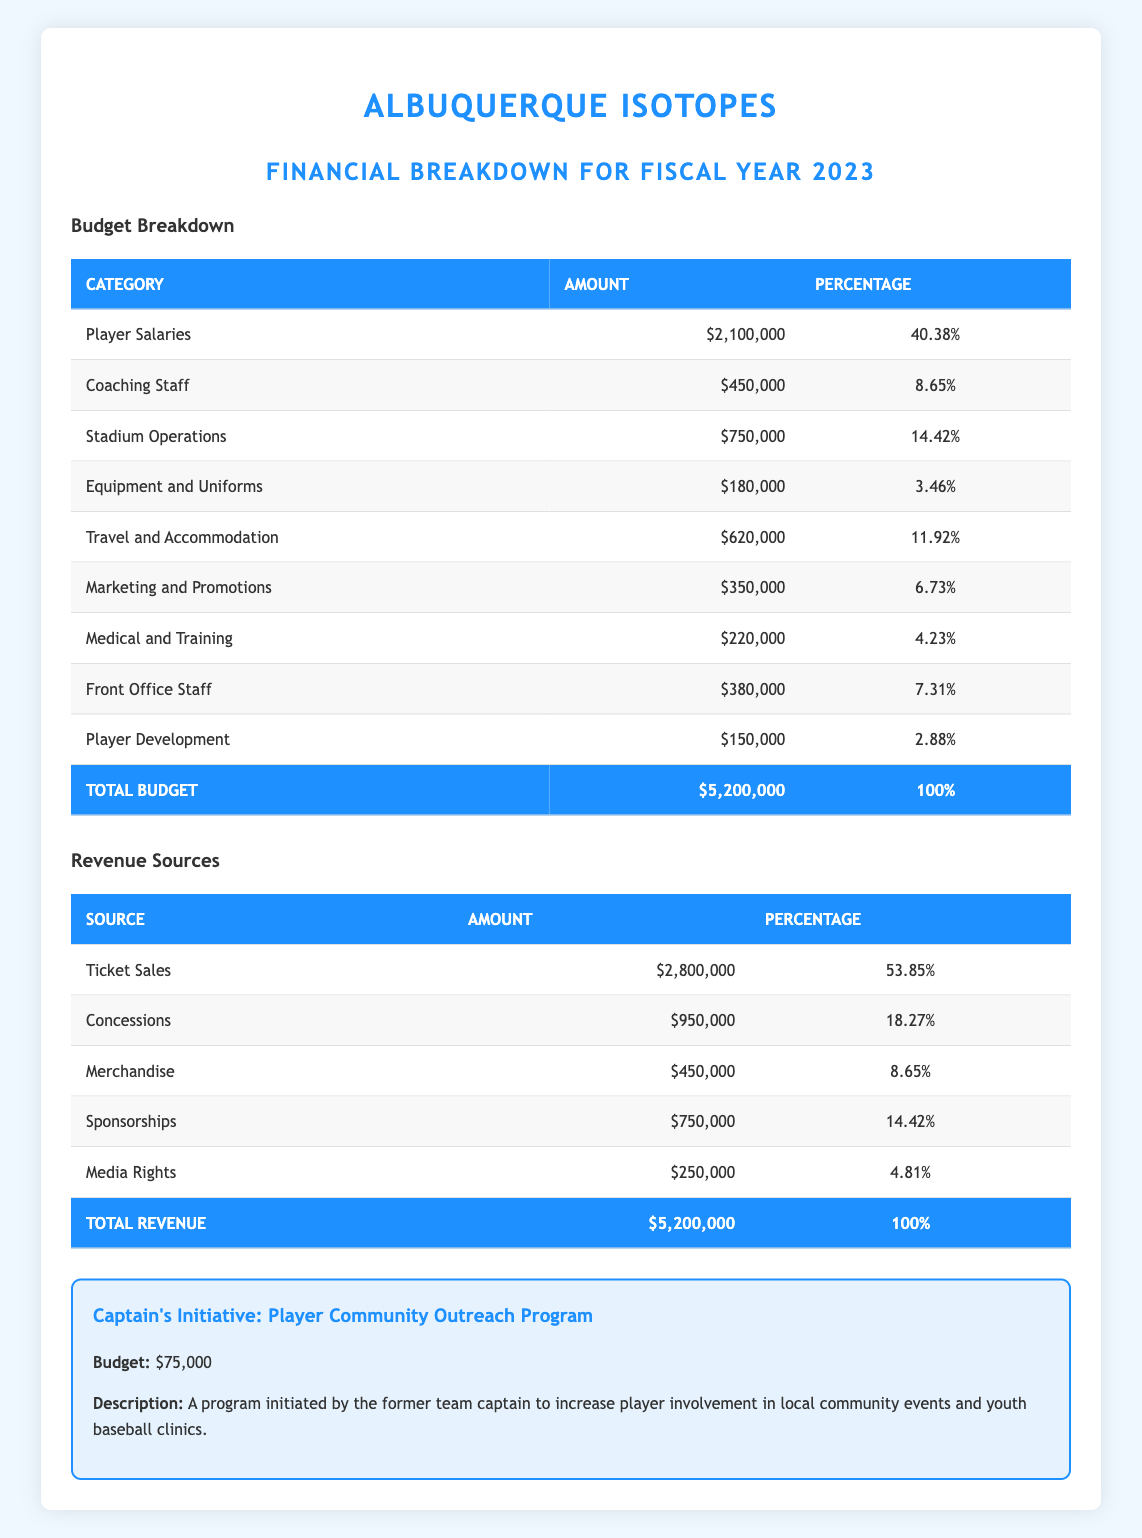What is the total budget for the Albuquerque Isotopes in 2023? The total budget listed in the table shows $5,200,000 for the fiscal year 2023.
Answer: 5,200,000 What percentage of the total budget is allocated to player salaries? The budget breakdown indicates that player salaries are allocated 40.38% of the total budget, which is $2,100,000.
Answer: 40.38% What is the amount allocated to coaching staff? The table lists the coaching staff budget as $450,000.
Answer: 450,000 What is the total revenue generated from ticket sales and concessions combined? Adding ticket sales ($2,800,000) and concessions ($950,000) gives a total of $3,750,000.
Answer: 3,750,000 Is the budget for marketing and promotions greater than that for medical and training? Comparing the values, marketing and promotions is $350,000, and medical and training is $220,000. Since $350,000 > $220,000, the statement is true.
Answer: Yes What is the combined percentage of the budget for travel and accommodation and stadium operations? Travel and accommodation are 11.92% and stadium operations are 14.42%. Adding these gives 11.92% + 14.42% = 26.34%.
Answer: 26.34% How much is spent on player development in comparison to equipment and uniforms? Player development is $150,000 and equipment and uniforms are $180,000. Since $150,000 < $180,000, more is spent on equipment and uniforms.
Answer: Less How is the budget for the captain's initiative compared to the total budget? The captain's initiative budget is $75,000. To find the percentage of the total budget this represents: (75,000 / 5,200,000) * 100 = 1.44%, showing it is a small portion of the total budget.
Answer: 1.44% Is the revenue from merchandise less than the revenue from media rights? The merchandise revenue is $450,000 and the media rights revenue is $250,000. Since $450,000 > $250,000, this statement is false.
Answer: No 